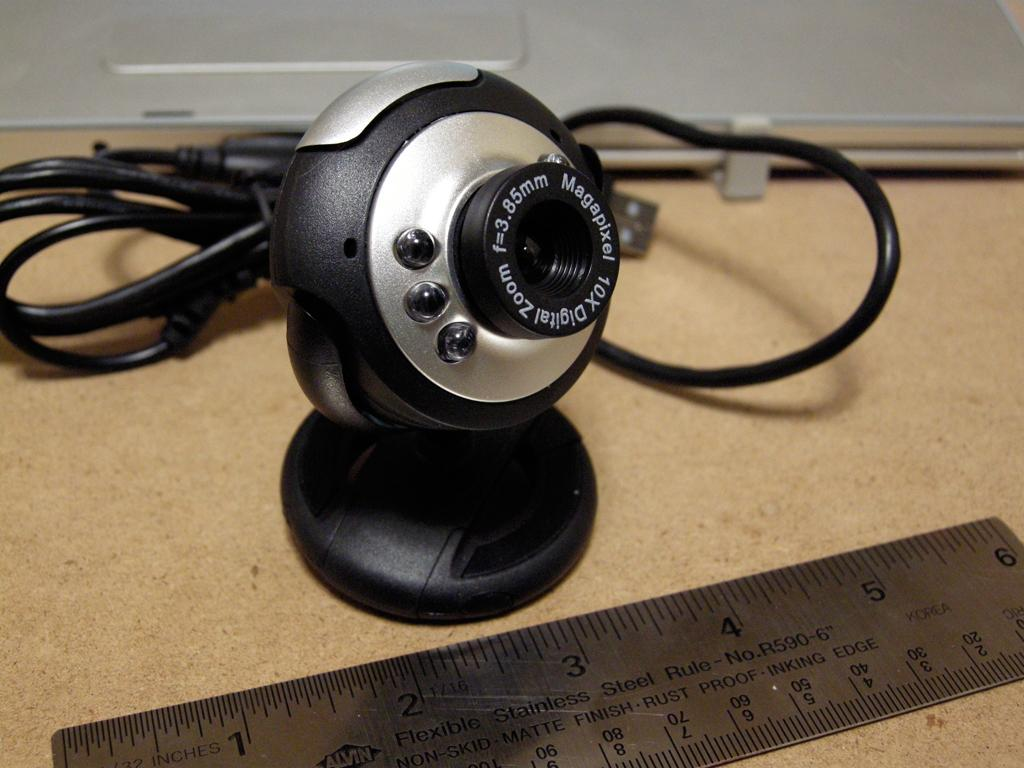<image>
Offer a succinct explanation of the picture presented. Camera with Magapixel in white letters behind a ruler. 